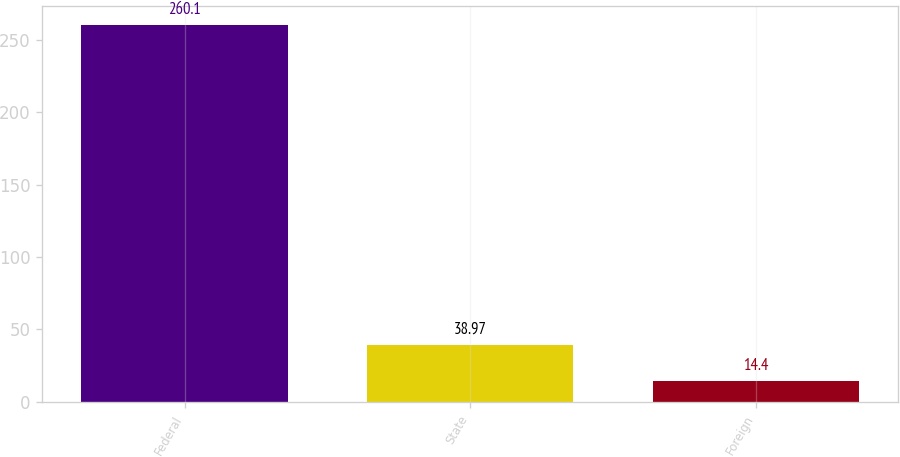<chart> <loc_0><loc_0><loc_500><loc_500><bar_chart><fcel>Federal<fcel>State<fcel>Foreign<nl><fcel>260.1<fcel>38.97<fcel>14.4<nl></chart> 